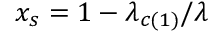Convert formula to latex. <formula><loc_0><loc_0><loc_500><loc_500>x _ { s } = 1 - \lambda _ { c ( 1 ) } / \lambda</formula> 